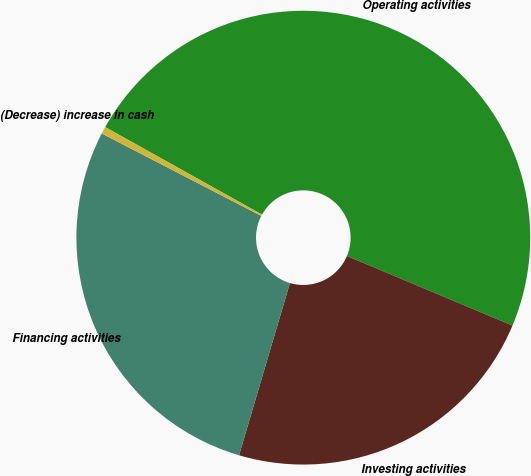<chart> <loc_0><loc_0><loc_500><loc_500><pie_chart><fcel>Operating activities<fcel>Investing activities<fcel>Financing activities<fcel>(Decrease) increase in cash<nl><fcel>48.23%<fcel>23.24%<fcel>28.02%<fcel>0.51%<nl></chart> 